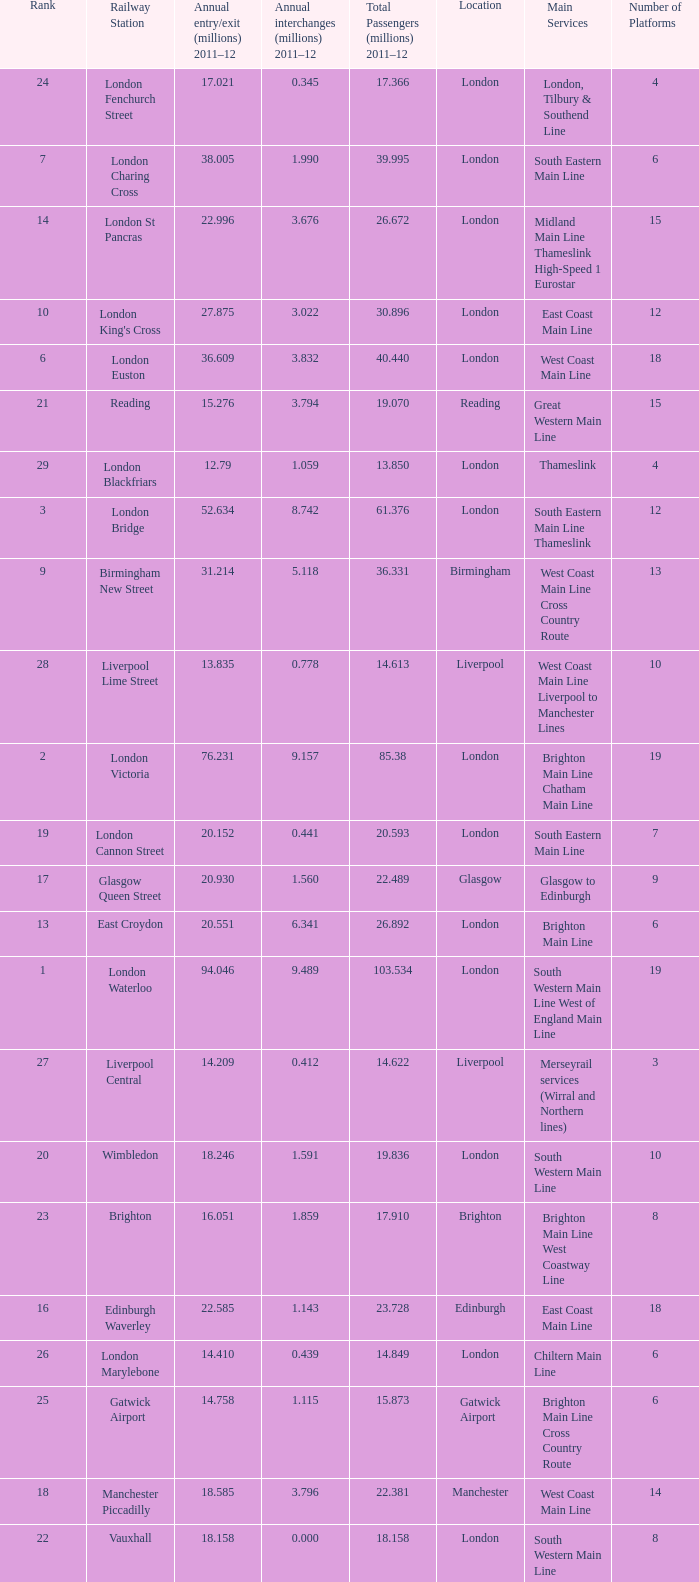Which location has 103.534 million passengers in 2011-12?  London. 